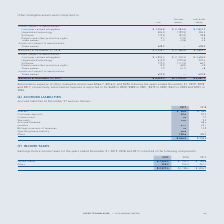From Roper Technologies's financial document, What are the expected amortization expenses in 2020 and 2021, respectively? The document shows two values: $400 and $383. From the document: "ortization expense is expected to be $400 in 2020, $383 in 2021, $379 in 2022, $347 in 2023 and $321 in 2024. spectively. Amortization expense is expe..." Also, What is the total net book value of other intangible assets as at December 31, 2019? According to the financial document, $ 4,667.7. The relevant text states: "alances at December 31, 2019 $ 6,420.3 $ (1,752.6) $ 4,667.7..." Also, What are the accumulated amortizations in 2018 and 2019, respectively? The document shows two values: $(1,386.6) and $(1,752.6). From the document: "Balances at December 31, 2019 $ 6,420.3 $ (1,752.6) $ 4,667.7 Balances at December 31, 2018 $ 5,228.7 $ (1,386.6) $ 3,842.1..." Also, can you calculate: What is the percentage change in balances of net book value from 2018 to 2019? To answer this question, I need to perform calculations using the financial data. The calculation is: (4,667.7-3,842.1)/3,842.1 , which equals 21.49 (percentage). This is based on the information: "nces at December 31, 2019 $ 6,420.3 $ (1,752.6) $ 4,667.7 nces at December 31, 2018 $ 5,228.7 $ (1,386.6) $ 3,842.1..." The key data points involved are: 3,842.1, 4,667.7. Also, can you calculate: What is the proportion of the cost of software and trade names over total cost in 2018? To answer this question, I need to perform calculations using the financial data. The calculation is: (172.0+7.3)/5,228.7 , which equals 0.03. This is based on the information: "Balances at December 31, 2018 $ 5,228.7 $ (1,386.6) $ 3,842.1 Trade names 7.3 (2.8) 4.5 Software 172.0 (93.2) 78.8..." The key data points involved are: 172.0, 5,228.7, 7.3. Also, can you calculate: What is the percentage change in the cost of customer-related intangible assets in 2019 compared to 2018? To answer this question, I need to perform calculations using the financial data. The calculation is: (4,955.4-3,926.8)/3,926.8 , which equals 26.19 (percentage). This is based on the information: "Customer related intangibles $ 4,955.4 $ (1,349.4) $ 3,606.0 Customer related intangibles $ 3,926.8 $ (1,083.6) $ 2,843.2..." The key data points involved are: 3,926.8, 4,955.4. 